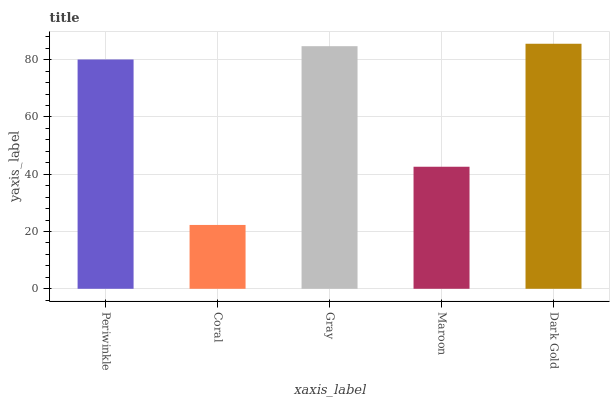Is Coral the minimum?
Answer yes or no. Yes. Is Dark Gold the maximum?
Answer yes or no. Yes. Is Gray the minimum?
Answer yes or no. No. Is Gray the maximum?
Answer yes or no. No. Is Gray greater than Coral?
Answer yes or no. Yes. Is Coral less than Gray?
Answer yes or no. Yes. Is Coral greater than Gray?
Answer yes or no. No. Is Gray less than Coral?
Answer yes or no. No. Is Periwinkle the high median?
Answer yes or no. Yes. Is Periwinkle the low median?
Answer yes or no. Yes. Is Gray the high median?
Answer yes or no. No. Is Gray the low median?
Answer yes or no. No. 